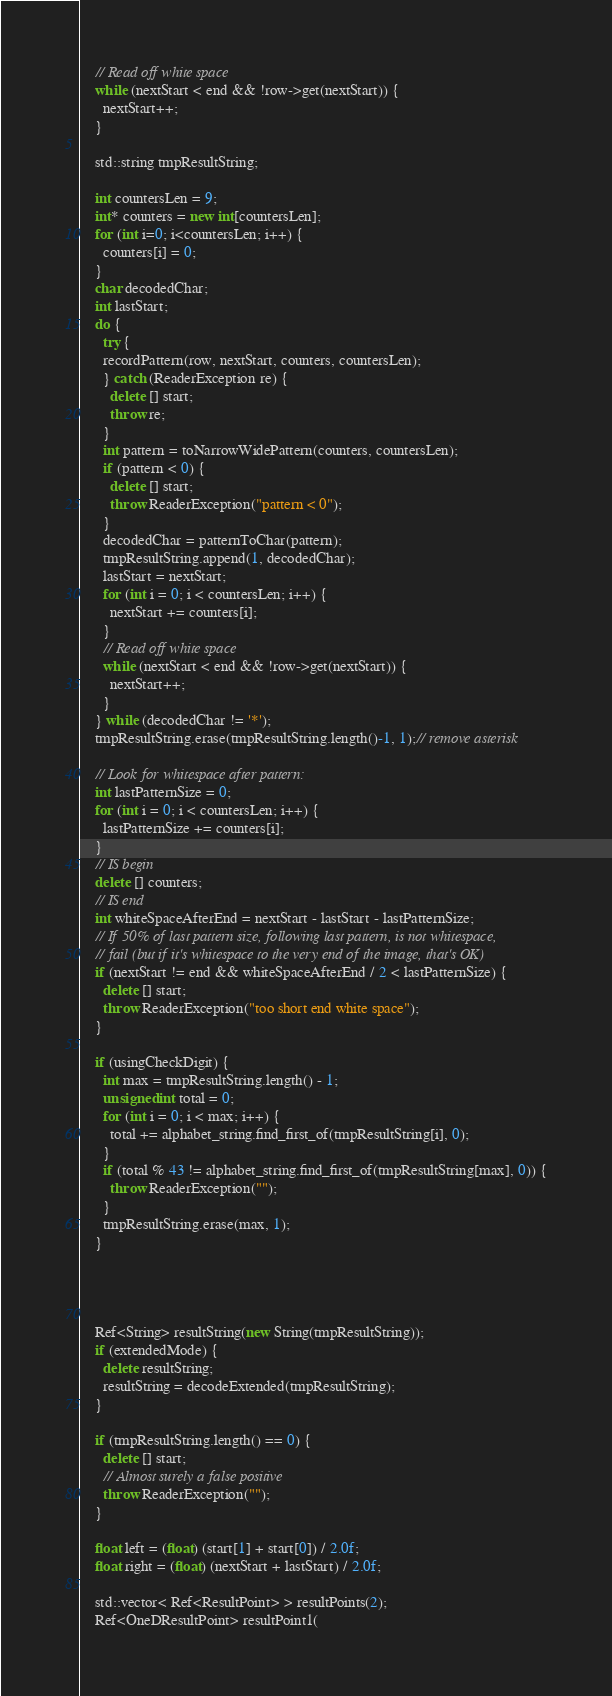Convert code to text. <code><loc_0><loc_0><loc_500><loc_500><_C++_>
    // Read off white space
    while (nextStart < end && !row->get(nextStart)) {
      nextStart++;
    }

    std::string tmpResultString;

    int countersLen = 9;
    int* counters = new int[countersLen];
    for (int i=0; i<countersLen; i++) {
      counters[i] = 0;
    }
    char decodedChar;
    int lastStart;
    do {
      try {
      recordPattern(row, nextStart, counters, countersLen);
      } catch (ReaderException re) {
        delete [] start;
        throw re;
      }
      int pattern = toNarrowWidePattern(counters, countersLen);
      if (pattern < 0) {
        delete [] start;
        throw ReaderException("pattern < 0");
      }
      decodedChar = patternToChar(pattern);
      tmpResultString.append(1, decodedChar);
      lastStart = nextStart;
      for (int i = 0; i < countersLen; i++) {
        nextStart += counters[i];
      }
      // Read off white space
      while (nextStart < end && !row->get(nextStart)) {
        nextStart++;
      }
    } while (decodedChar != '*');
    tmpResultString.erase(tmpResultString.length()-1, 1);// remove asterisk

    // Look for whitespace after pattern:
    int lastPatternSize = 0;
    for (int i = 0; i < countersLen; i++) {
      lastPatternSize += counters[i];
    }
    // IS begin
    delete [] counters;
    // IS end
    int whiteSpaceAfterEnd = nextStart - lastStart - lastPatternSize;
    // If 50% of last pattern size, following last pattern, is not whitespace,
    // fail (but if it's whitespace to the very end of the image, that's OK)
    if (nextStart != end && whiteSpaceAfterEnd / 2 < lastPatternSize) {
      delete [] start;
      throw ReaderException("too short end white space");
    }

    if (usingCheckDigit) {
      int max = tmpResultString.length() - 1;
      unsigned int total = 0;
      for (int i = 0; i < max; i++) {
        total += alphabet_string.find_first_of(tmpResultString[i], 0);
      }
      if (total % 43 != alphabet_string.find_first_of(tmpResultString[max], 0)) {
        throw ReaderException("");
      }
      tmpResultString.erase(max, 1);
    }




    Ref<String> resultString(new String(tmpResultString));
    if (extendedMode) {
      delete resultString;
      resultString = decodeExtended(tmpResultString);
    }

    if (tmpResultString.length() == 0) {
      delete [] start;
      // Almost surely a false positive
      throw ReaderException("");
    }

    float left = (float) (start[1] + start[0]) / 2.0f;
    float right = (float) (nextStart + lastStart) / 2.0f;

    std::vector< Ref<ResultPoint> > resultPoints(2);
    Ref<OneDResultPoint> resultPoint1(</code> 